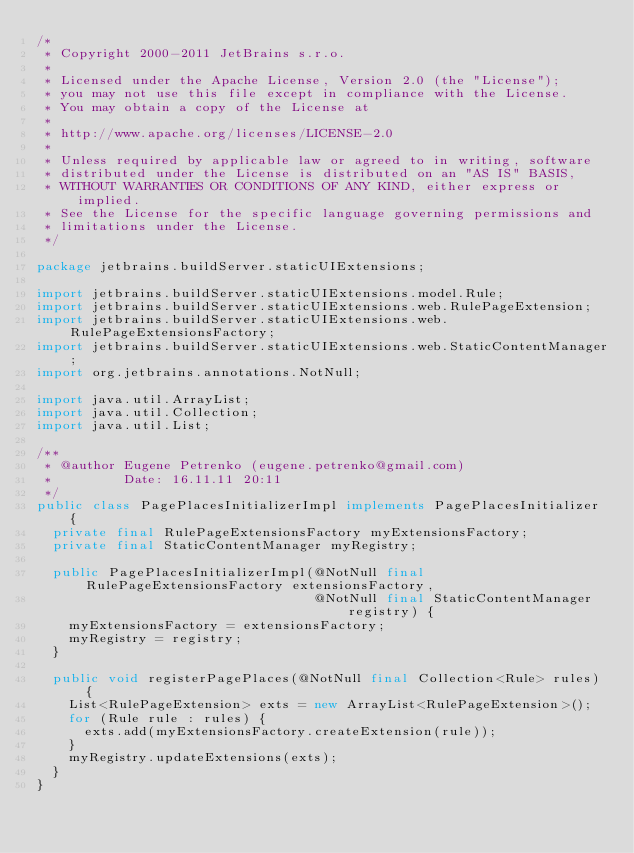Convert code to text. <code><loc_0><loc_0><loc_500><loc_500><_Java_>/*
 * Copyright 2000-2011 JetBrains s.r.o.
 *
 * Licensed under the Apache License, Version 2.0 (the "License");
 * you may not use this file except in compliance with the License.
 * You may obtain a copy of the License at
 *
 * http://www.apache.org/licenses/LICENSE-2.0
 *
 * Unless required by applicable law or agreed to in writing, software
 * distributed under the License is distributed on an "AS IS" BASIS,
 * WITHOUT WARRANTIES OR CONDITIONS OF ANY KIND, either express or implied.
 * See the License for the specific language governing permissions and
 * limitations under the License.
 */

package jetbrains.buildServer.staticUIExtensions;

import jetbrains.buildServer.staticUIExtensions.model.Rule;
import jetbrains.buildServer.staticUIExtensions.web.RulePageExtension;
import jetbrains.buildServer.staticUIExtensions.web.RulePageExtensionsFactory;
import jetbrains.buildServer.staticUIExtensions.web.StaticContentManager;
import org.jetbrains.annotations.NotNull;

import java.util.ArrayList;
import java.util.Collection;
import java.util.List;

/**
 * @author Eugene Petrenko (eugene.petrenko@gmail.com)
 *         Date: 16.11.11 20:11
 */
public class PagePlacesInitializerImpl implements PagePlacesInitializer {
  private final RulePageExtensionsFactory myExtensionsFactory;
  private final StaticContentManager myRegistry;

  public PagePlacesInitializerImpl(@NotNull final RulePageExtensionsFactory extensionsFactory,
                                   @NotNull final StaticContentManager registry) {
    myExtensionsFactory = extensionsFactory;
    myRegistry = registry;
  }

  public void registerPagePlaces(@NotNull final Collection<Rule> rules) {
    List<RulePageExtension> exts = new ArrayList<RulePageExtension>();
    for (Rule rule : rules) {
      exts.add(myExtensionsFactory.createExtension(rule));
    }
    myRegistry.updateExtensions(exts);
  }
}
</code> 